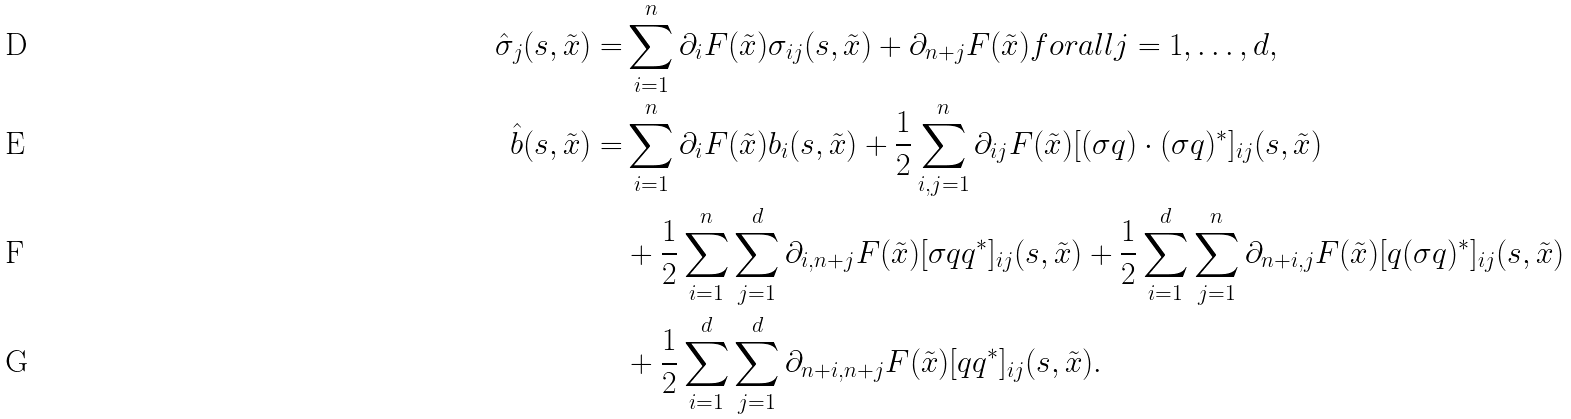<formula> <loc_0><loc_0><loc_500><loc_500>\hat { \sigma } _ { j } ( s , \tilde { x } ) = & \sum _ { i = 1 } ^ { n } \partial _ { i } F ( \tilde { x } ) \sigma _ { i j } ( s , \tilde { x } ) + \partial _ { n + j } F ( \tilde { x } ) f o r a l l j = 1 , \dots , d , \\ \hat { b } ( s , \tilde { x } ) = & \sum _ { i = 1 } ^ { n } \partial _ { i } F ( \tilde { x } ) b _ { i } ( s , \tilde { x } ) + \frac { 1 } { 2 } \sum _ { i , j = 1 } ^ { n } \partial _ { i j } F ( \tilde { x } ) [ ( \sigma q ) \cdot ( \sigma q ) ^ { * } ] _ { i j } ( s , \tilde { x } ) \\ & + \frac { 1 } { 2 } \sum _ { i = 1 } ^ { n } \sum _ { j = 1 } ^ { d } \partial _ { i , n + j } F ( \tilde { x } ) [ \sigma q q ^ { * } ] _ { i j } ( s , \tilde { x } ) + \frac { 1 } { 2 } \sum _ { i = 1 } ^ { d } \sum _ { j = 1 } ^ { n } \partial _ { n + i , j } F ( \tilde { x } ) [ q ( \sigma q ) ^ { * } ] _ { i j } ( s , \tilde { x } ) \\ & + \frac { 1 } { 2 } \sum _ { i = 1 } ^ { d } \sum _ { j = 1 } ^ { d } \partial _ { n + i , n + j } F ( \tilde { x } ) [ q q ^ { * } ] _ { i j } ( s , \tilde { x } ) .</formula> 